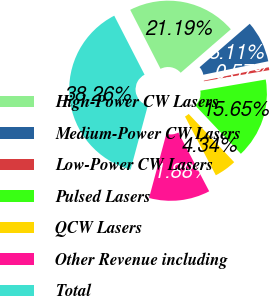<chart> <loc_0><loc_0><loc_500><loc_500><pie_chart><fcel>High-Power CW Lasers<fcel>Medium-Power CW Lasers<fcel>Low-Power CW Lasers<fcel>Pulsed Lasers<fcel>QCW Lasers<fcel>Other Revenue including<fcel>Total<nl><fcel>21.19%<fcel>8.11%<fcel>0.57%<fcel>15.65%<fcel>4.34%<fcel>11.88%<fcel>38.26%<nl></chart> 